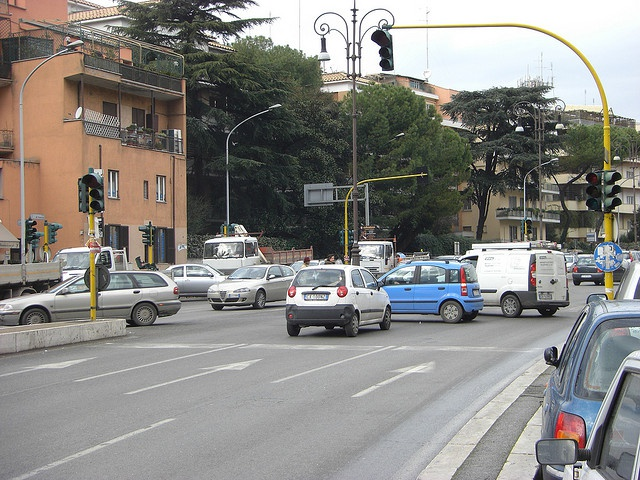Describe the objects in this image and their specific colors. I can see car in gray and darkgray tones, car in gray, darkgray, lightgray, and black tones, truck in gray, white, darkgray, and black tones, car in gray, darkgray, black, and lightgray tones, and car in gray, white, darkgray, and black tones in this image. 